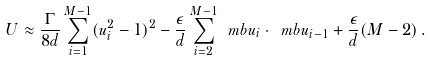<formula> <loc_0><loc_0><loc_500><loc_500>U \approx \frac { \Gamma } { 8 d } \sum _ { i = 1 } ^ { M - 1 } ( u _ { i } ^ { 2 } - 1 ) ^ { 2 } - \frac { \epsilon } { d } \sum _ { i = 2 } ^ { M - 1 } \ m b { u } _ { i } \cdot \ m b { u } _ { i - 1 } + \frac { \epsilon } { d } ( M - 2 ) \, .</formula> 